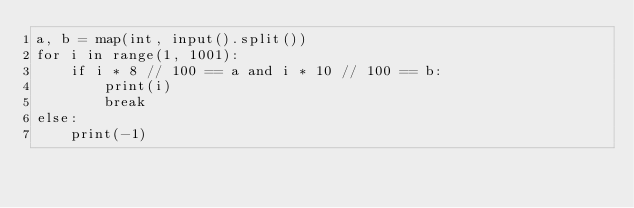Convert code to text. <code><loc_0><loc_0><loc_500><loc_500><_Python_>a, b = map(int, input().split())
for i in range(1, 1001):
    if i * 8 // 100 == a and i * 10 // 100 == b:
        print(i)
        break
else:
    print(-1)
</code> 